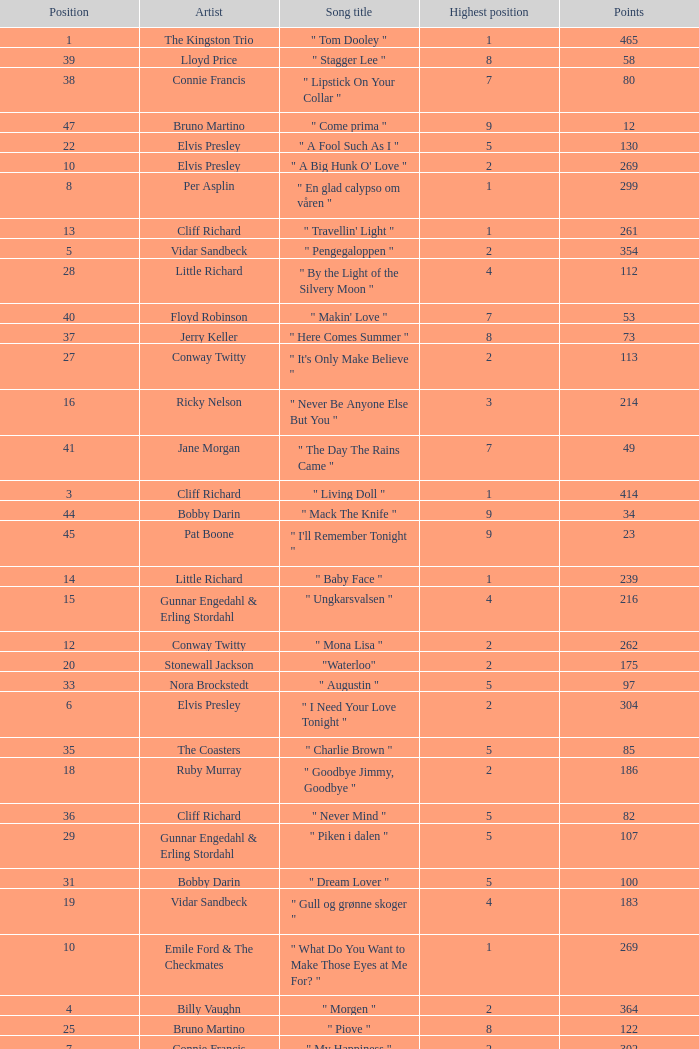What is the nme of the song performed by billy vaughn? " Morgen ". 